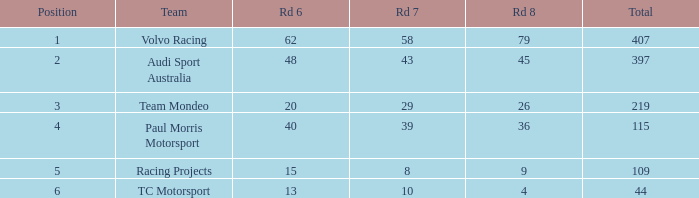What is the average value for Rd 8 in a position less than 2 for Audi Sport Australia? None. 